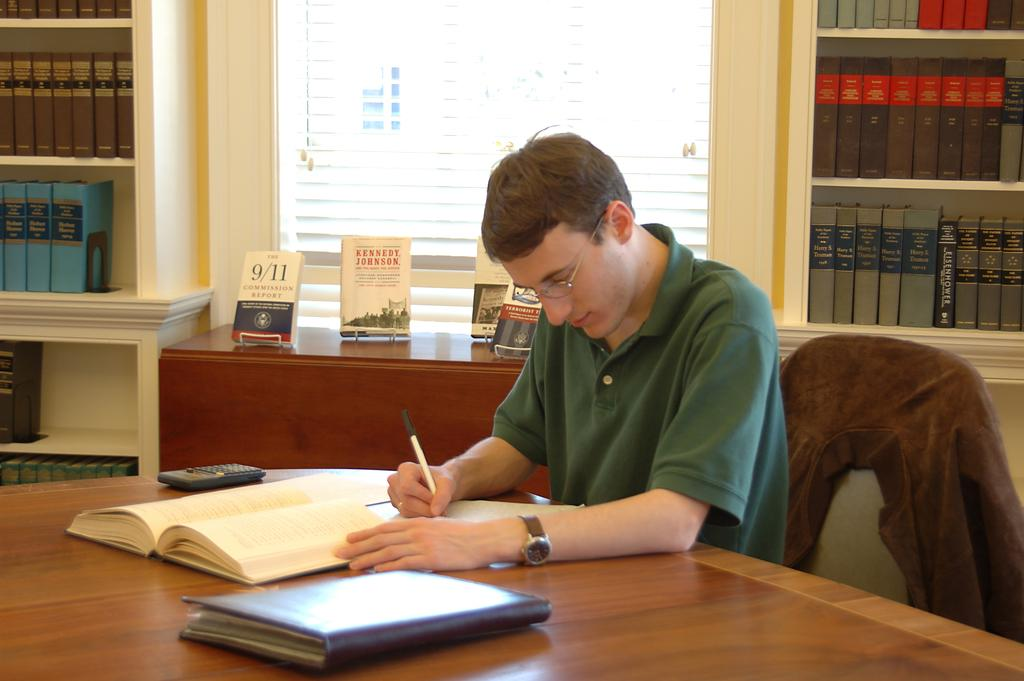What is the man in the foreground doing? The man in the foreground is writing. What objects are on the table? There are books and a calculator on the table. Where can more books be found in the image? There are books on the bookshelves and on the desk. What is visible in the background of the image? There is a window in the background. What type of reward is the governor presenting to the man in the image? There is no governor or reward present in the image; it only features a man writing and various objects related to studying or working. 